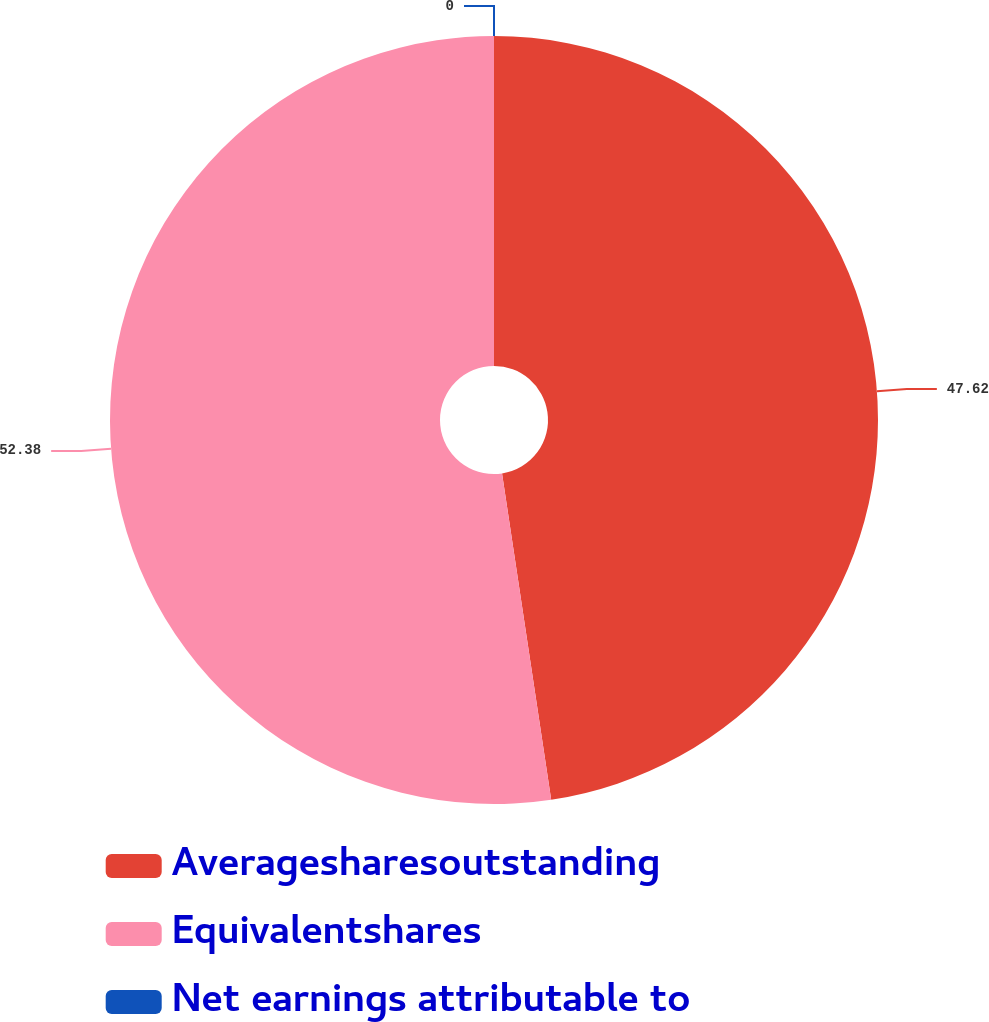Convert chart to OTSL. <chart><loc_0><loc_0><loc_500><loc_500><pie_chart><fcel>Averagesharesoutstanding<fcel>Equivalentshares<fcel>Net earnings attributable to<nl><fcel>47.62%<fcel>52.38%<fcel>0.0%<nl></chart> 